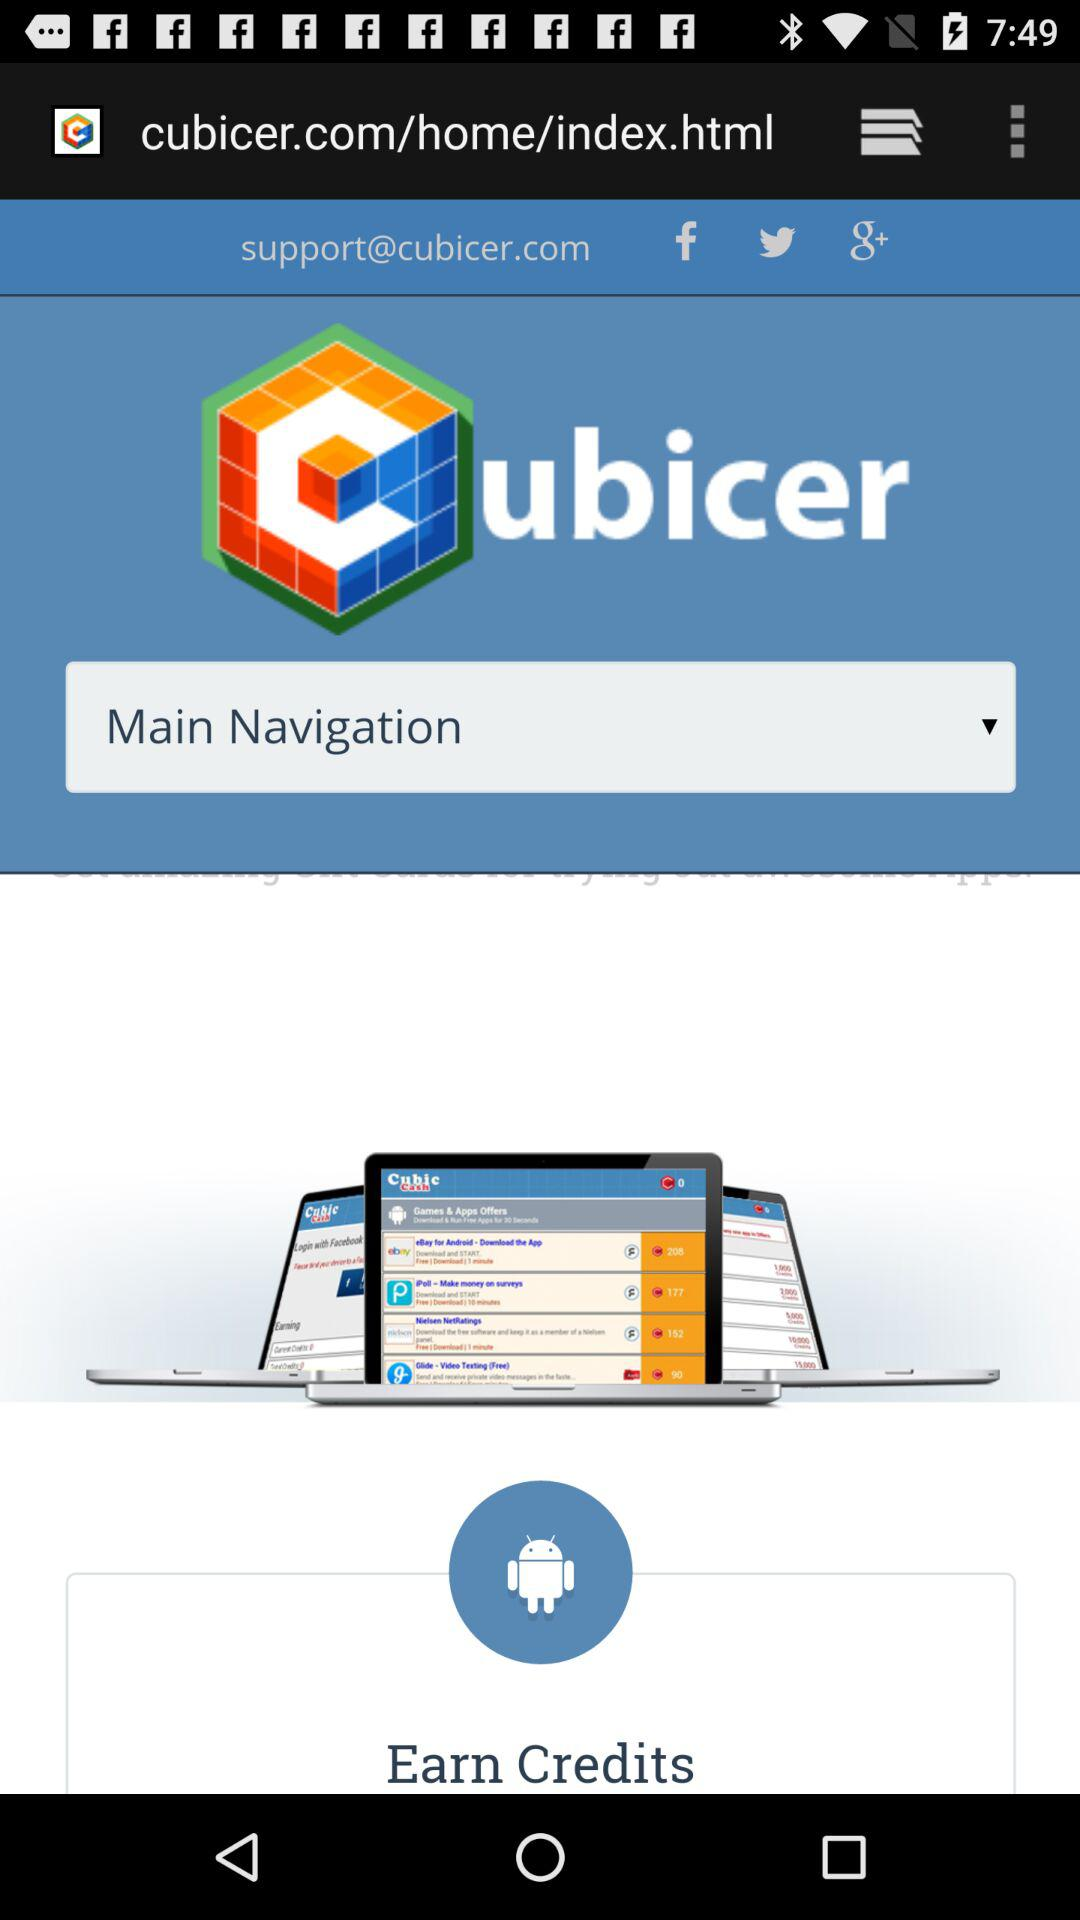What is the email address? The email address is support@cubicer.com. 